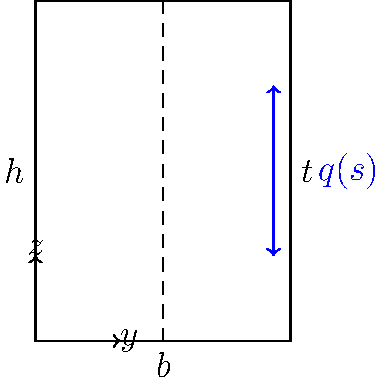Consider a thin-walled open section with a rectangular cross-section subjected to a torsional moment $M_t$. The cross-section has a width $b$, height $h$, and uniform thickness $t$. Derive an expression for the maximum shear flow $q_{max}$ in terms of $M_t$, $b$, $h$, and $t$. Assume that $h > b$ and the material is linearly elastic. To solve this problem, we'll follow these steps:

1) The shear flow distribution in a thin-walled open section under torsion is given by:

   $$q(s) = \frac{M_t}{2A_0}\cdot s$$

   where $A_0$ is the area enclosed by the centerline of the cross-section, and $s$ is the distance along the centerline from one end.

2) Calculate $A_0$:
   $$A_0 = (b-t)(h-t)$$

3) The maximum shear flow occurs at the end of the longest side (height) of the rectangle. The distance $s$ at this point is:
   $$s_{max} = 2(b-t) + (h-t)$$

4) Substituting these into the shear flow equation:

   $$q_{max} = \frac{M_t}{2(b-t)(h-t)} \cdot [2(b-t) + (h-t)]$$

5) Simplify:

   $$q_{max} = \frac{M_t}{2(b-t)(h-t)} \cdot [2b + h - 3t]$$

6) Since the section is thin-walled, we can assume $t << b$ and $t << h$. This allows us to approximate:

   $$q_{max} \approx \frac{M_t}{2bh} \cdot (2b + h)$$

This is the final expression for the maximum shear flow in terms of $M_t$, $b$, $h$, and $t$ (though $t$ has been eliminated in the approximation).
Answer: $$q_{max} \approx \frac{M_t(2b + h)}{2bh}$$ 